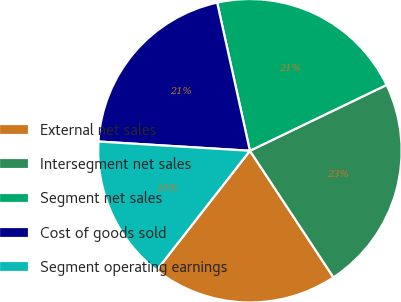Convert chart to OTSL. <chart><loc_0><loc_0><loc_500><loc_500><pie_chart><fcel>External net sales<fcel>Intersegment net sales<fcel>Segment net sales<fcel>Cost of goods sold<fcel>Segment operating earnings<nl><fcel>19.83%<fcel>22.86%<fcel>21.32%<fcel>20.57%<fcel>15.42%<nl></chart> 